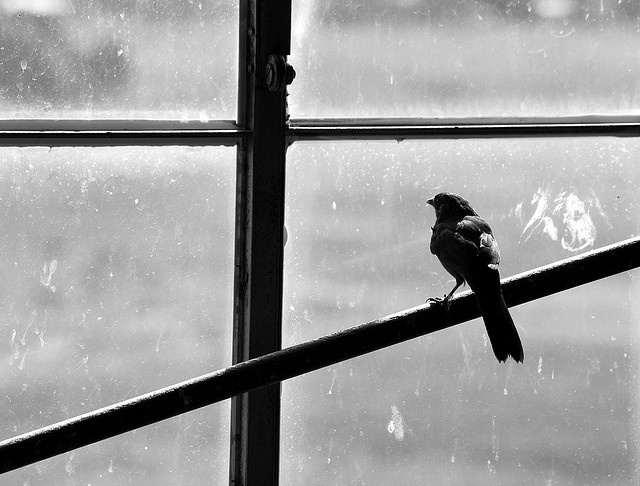Describe the objects in this image and their specific colors. I can see a bird in lightgray, black, darkgray, and gray tones in this image. 